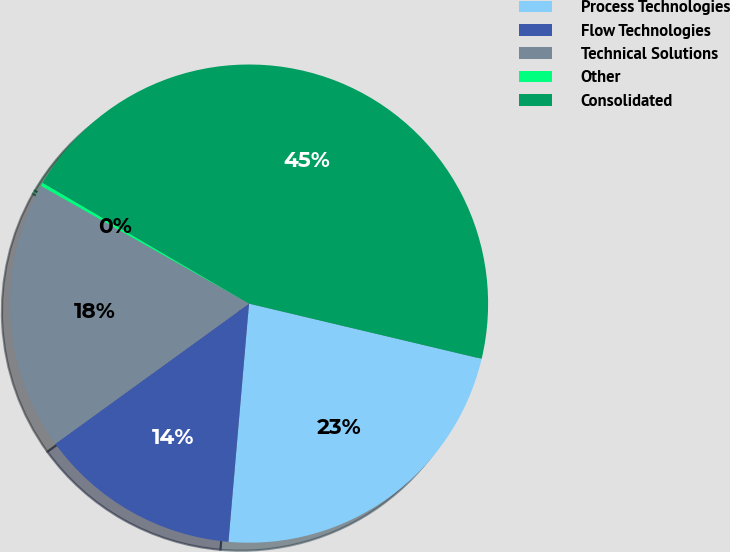Convert chart. <chart><loc_0><loc_0><loc_500><loc_500><pie_chart><fcel>Process Technologies<fcel>Flow Technologies<fcel>Technical Solutions<fcel>Other<fcel>Consolidated<nl><fcel>22.66%<fcel>13.66%<fcel>18.16%<fcel>0.24%<fcel>45.27%<nl></chart> 